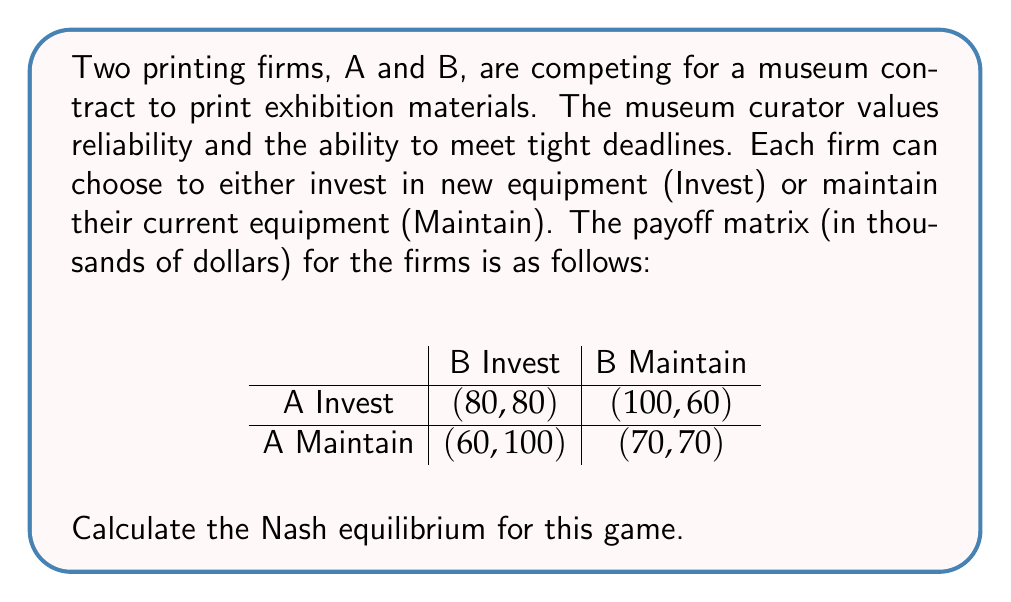Help me with this question. To find the Nash equilibrium, we need to determine the best response for each firm given the other firm's strategy.

1. For Firm A:
   - If B Invests: A's best response is to Invest (80 > 60)
   - If B Maintains: A's best response is to Invest (100 > 70)

2. For Firm B:
   - If A Invests: B's best response is to Invest (80 > 60)
   - If A Maintains: B's best response is to Invest (100 > 70)

We can see that regardless of what the other firm does, both firms' best strategy is to Invest. This leads us to the Nash equilibrium.

To confirm, let's check if any firm has an incentive to deviate:
- If A switches to Maintain while B Invests: A's payoff decreases from 80 to 60
- If B switches to Maintain while A Invests: B's payoff decreases from 80 to 60

Since neither firm has an incentive to unilaterally change their strategy, we have found the Nash equilibrium.

The Nash equilibrium strategy profile is (Invest, Invest), resulting in payoffs of (80, 80).

This outcome aligns with the curator's preferences for reliability and meeting deadlines, as both firms investing in new equipment would likely improve their performance in these areas.
Answer: The Nash equilibrium is (Invest, Invest) with payoffs (80, 80). 